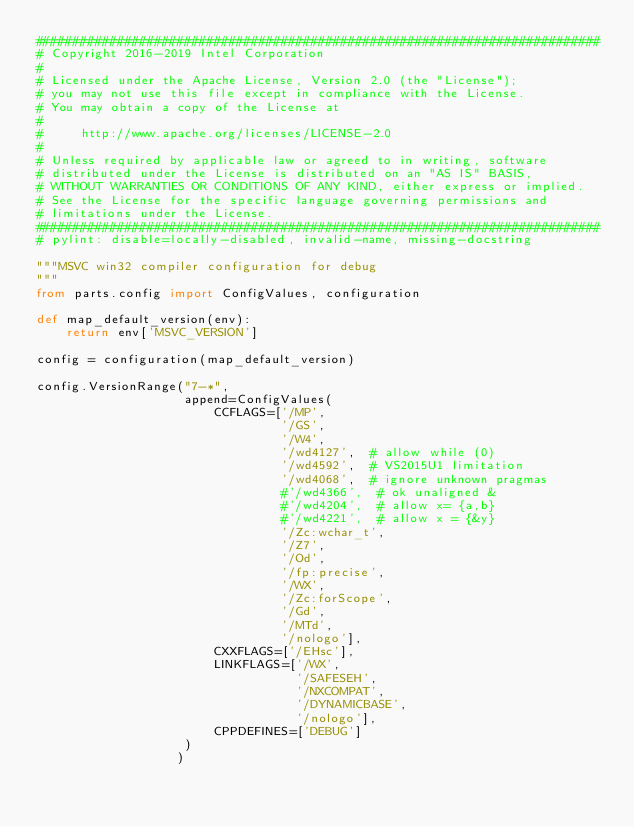Convert code to text. <code><loc_0><loc_0><loc_500><loc_500><_Python_>############################################################################
# Copyright 2016-2019 Intel Corporation
#
# Licensed under the Apache License, Version 2.0 (the "License");
# you may not use this file except in compliance with the License.
# You may obtain a copy of the License at
#
#     http://www.apache.org/licenses/LICENSE-2.0
#
# Unless required by applicable law or agreed to in writing, software
# distributed under the License is distributed on an "AS IS" BASIS,
# WITHOUT WARRANTIES OR CONDITIONS OF ANY KIND, either express or implied.
# See the License for the specific language governing permissions and
# limitations under the License.
############################################################################
# pylint: disable=locally-disabled, invalid-name, missing-docstring

"""MSVC win32 compiler configuration for debug
"""
from parts.config import ConfigValues, configuration

def map_default_version(env):
    return env['MSVC_VERSION']

config = configuration(map_default_version)

config.VersionRange("7-*",
                    append=ConfigValues(
                        CCFLAGS=['/MP',
                                 '/GS',
                                 '/W4',
                                 '/wd4127',  # allow while (0)
                                 '/wd4592',  # VS2015U1 limitation
                                 '/wd4068',  # ignore unknown pragmas
                                 #'/wd4366',  # ok unaligned &
                                 #'/wd4204',  # allow x= {a,b}
                                 #'/wd4221',  # allow x = {&y}
                                 '/Zc:wchar_t',
                                 '/Z7',
                                 '/Od',
                                 '/fp:precise',
                                 '/WX',
                                 '/Zc:forScope',
                                 '/Gd',
                                 '/MTd',
                                 '/nologo'],
                        CXXFLAGS=['/EHsc'],
                        LINKFLAGS=['/WX',
                                   '/SAFESEH',
                                   '/NXCOMPAT',
                                   '/DYNAMICBASE',
                                   '/nologo'],
                        CPPDEFINES=['DEBUG']
                    )
                   )
</code> 